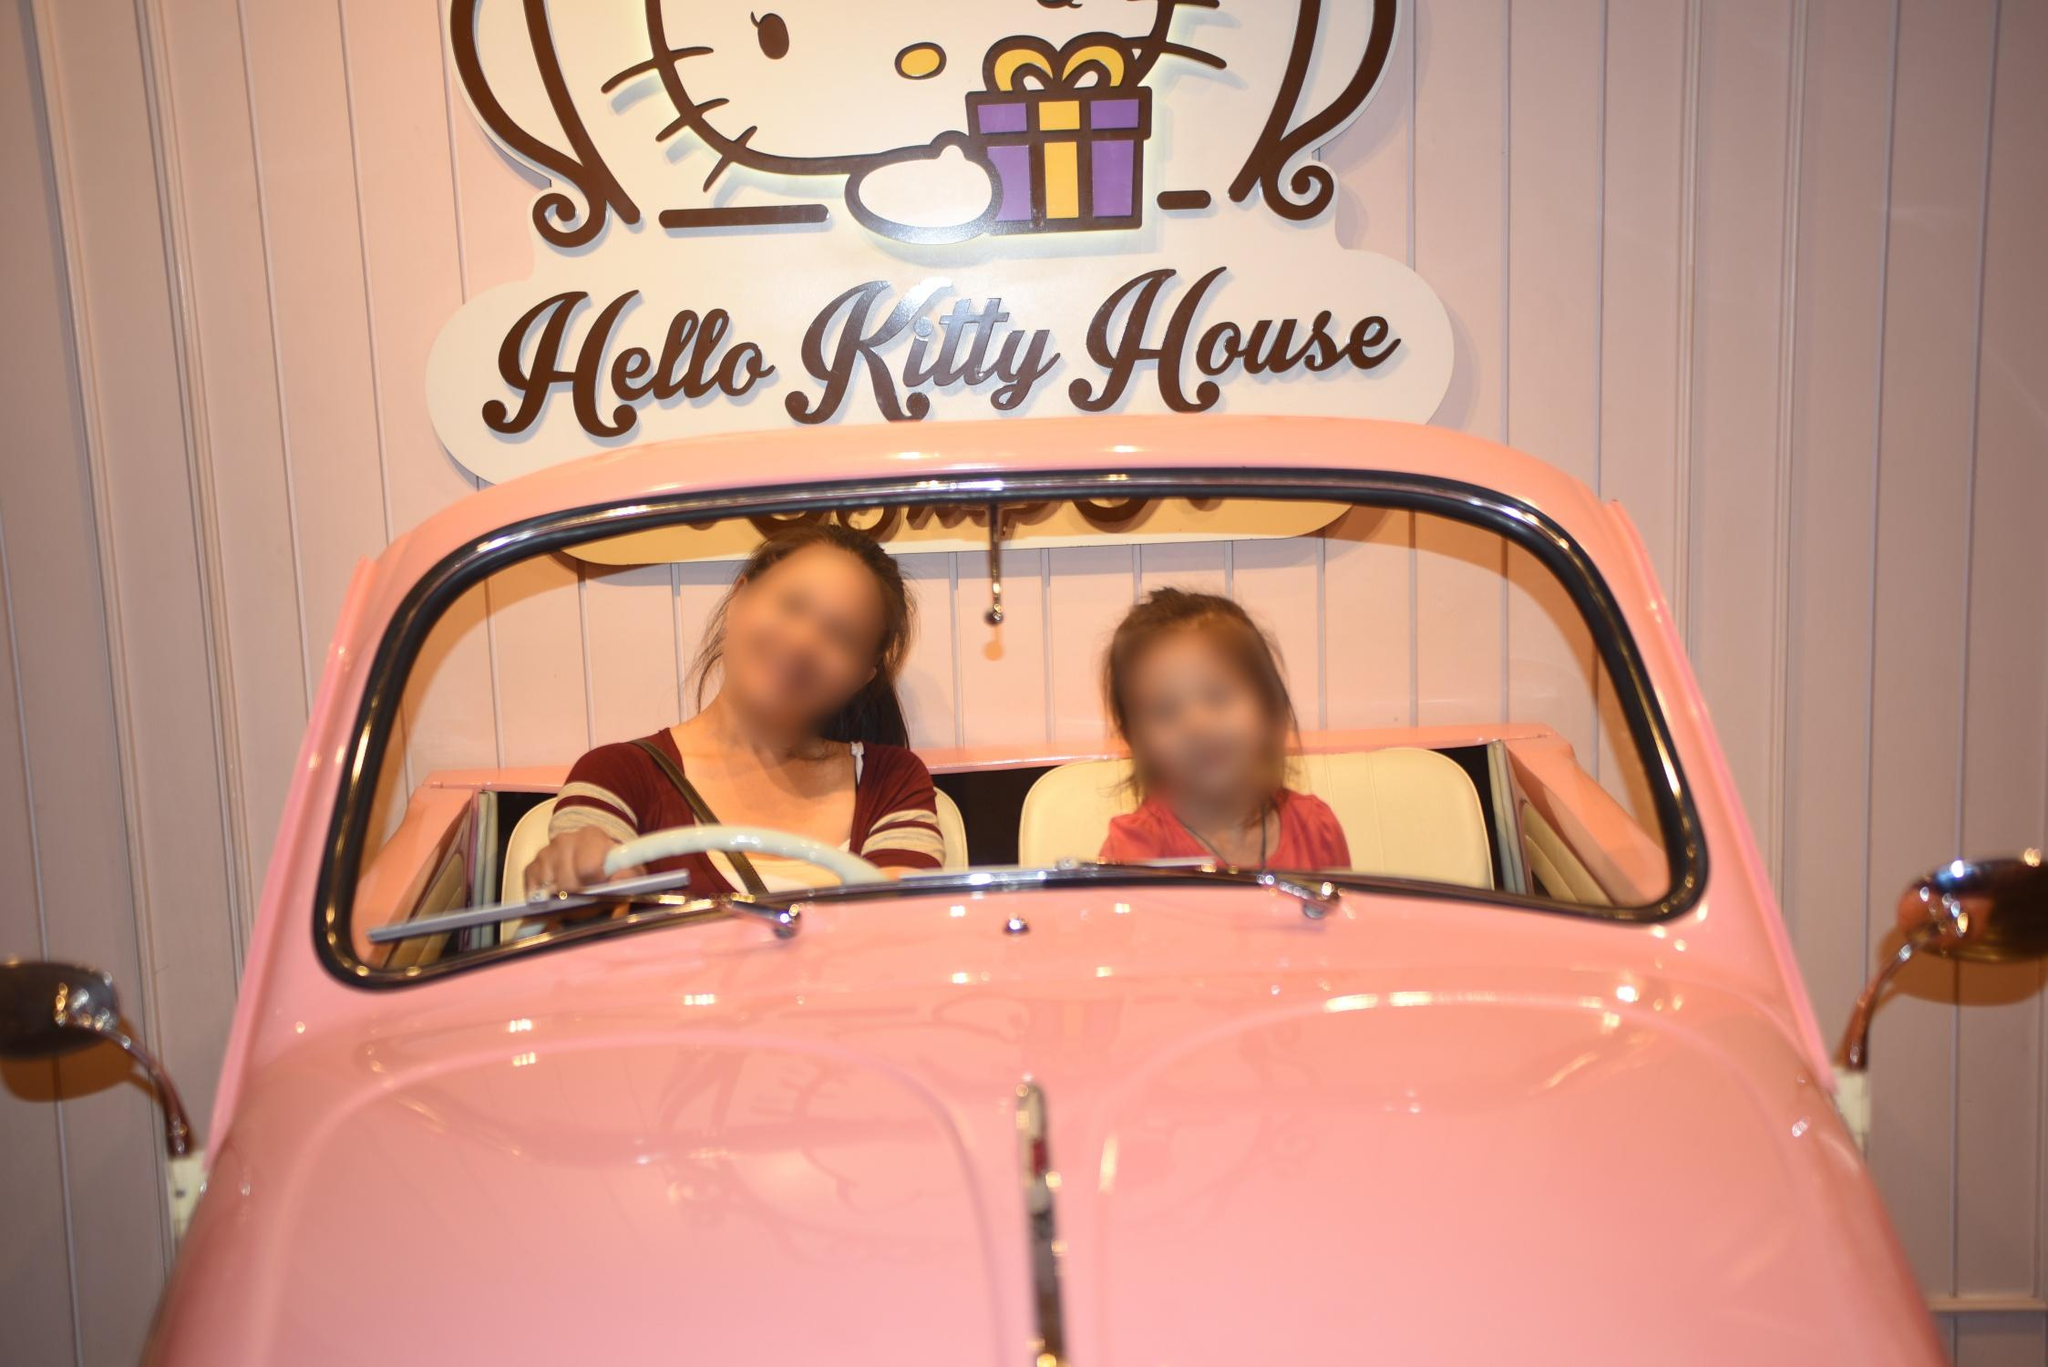What's happening in the scene? The image captures a vibrant scene in front of the "Hello Kitty House". A pink car with a white roof is parked, matching the pink and white striped wall of the house. The car's occupants are slightly blurred, suggesting they might be in motion. Above the car, a sign proudly announces "Hello Kitty House", accompanied by an illustration of the iconic cartoon cat holding a gift. The perspective of the photo is slightly elevated, looking down at the car from the front and left, giving a clear view of the scene. 